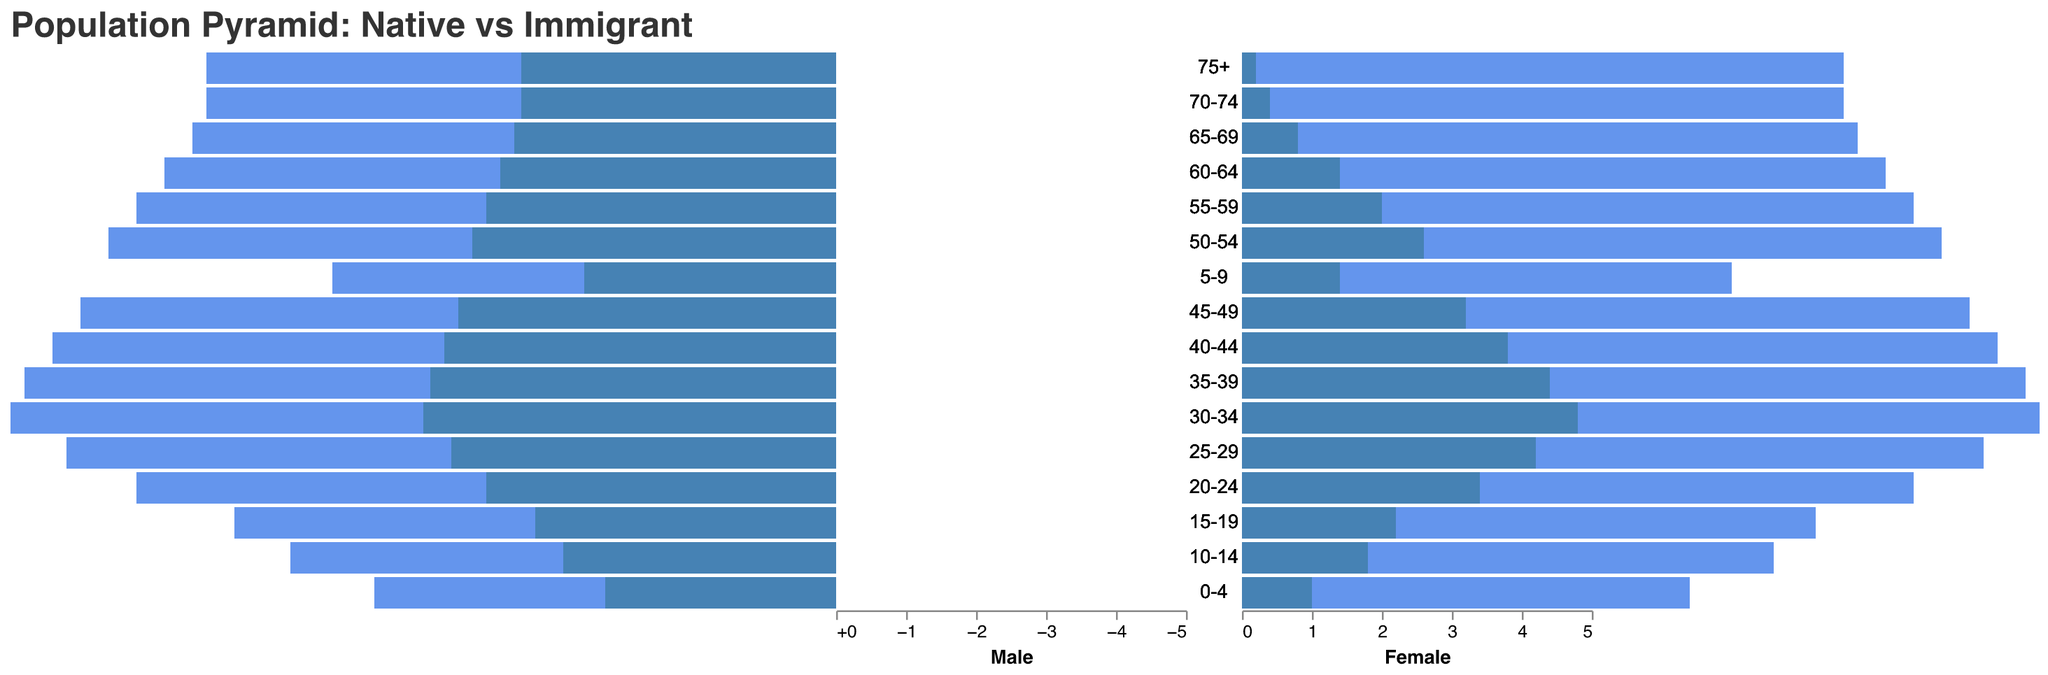How many age groups have more native males than native females in the population? Compare the "Male Native" and "Female Native" values for each age group. If the Male Native value is greater than the Female Native value, count that age group. The age groups 0-4, 5-9, 10-14, 15-19, 20-24, 25-29, 30-34, 35-39, 40-44, 45-49, 50-54, 55-59, 60-64, 65-69, 70-74, and 75+ all have more native males.
Answer: 16 Which age group has the highest percentage of male immigrants? Examine the "Male Immigrant" values across all age groups. The value is highest (2.5) for the 30-34 age group.
Answer: 30-34 What is the total percentage of female immigrants in the 25-29 age group? Reference the "Female Immigrant" value directly for the 25-29 age group, which is 2.1.
Answer: 2.1 What is the total immigrant population percentage (male + female) in the 35-39 age group? Add the "Male Immigrant" value (2.3) and the "Female Immigrant" value (2.2) from the 35-39 age group. 2.3 + 2.2 = 4.5.
Answer: 4.5 Which age group has the least native females? Compare the "Female Native" values across age groups and identify the smallest value. The smallest value, 2.7, is in the 0-4 age group.
Answer: 0-4 What is the proportion of female immigrants to native females in the 65-69 age group? Divide the "Female Immigrant" value (0.4) by the "Female Native" value (4.0) in that age group. 0.4 / 4.0 = 0.1 or 10%.
Answer: 0.1 Between which two age groups is the decrease in male immigrant population highest? Identify the highest decrease in "Male Immigrant" values between consecutive age groups by calculating the differences. The largest decrease is between 30-34 (2.5) and 35-39 (2.3), which is a decrease of 0.2.
Answer: 30-34 and 35-39 How does the total population (native and immigrant, male and female) of the 20-24 age group compare to the 75+ age group? Calculate the sum of "Male Native," "Male Immigrant," "Female Native," and "Female Immigrant" for both the 20-24 and 75+ age groups. For 20-24: 3.2 + 1.8 + 3.1 + 1.7 = 9.8. For 75+: 4.3 + 0.2 + 4.2 + 0.1 = 8.8. Compare the totals: 9.8 > 8.8.
Answer: 20-24 > 75+ What is the trend of native population percentages as age increases? Observe the "Male Native" and "Female Native" values across age groups. Both increase monotonically from the youngest age group (0-4) to the oldest (75+).
Answer: Increasing 